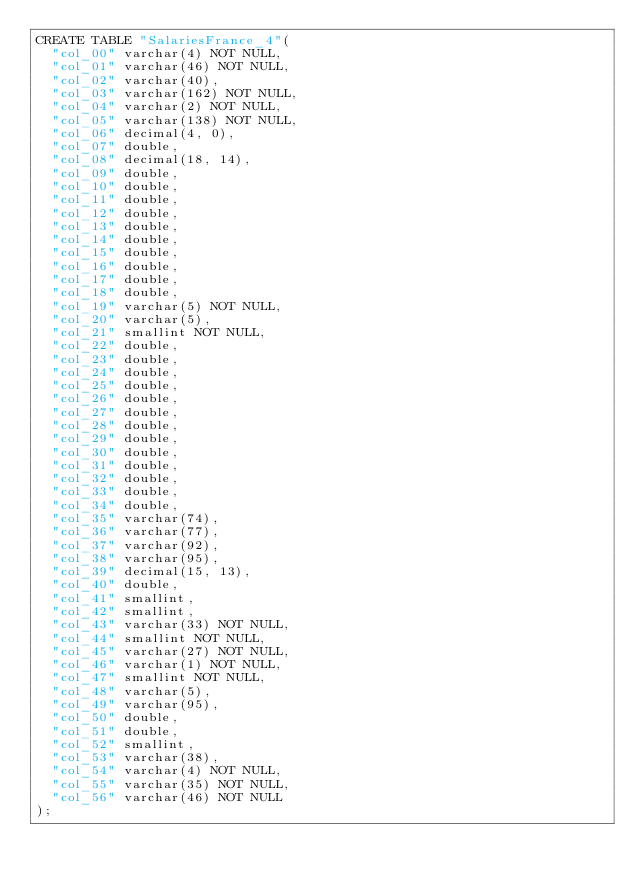<code> <loc_0><loc_0><loc_500><loc_500><_SQL_>CREATE TABLE "SalariesFrance_4"(
  "col_00" varchar(4) NOT NULL,
  "col_01" varchar(46) NOT NULL,
  "col_02" varchar(40),
  "col_03" varchar(162) NOT NULL,
  "col_04" varchar(2) NOT NULL,
  "col_05" varchar(138) NOT NULL,
  "col_06" decimal(4, 0),
  "col_07" double,
  "col_08" decimal(18, 14),
  "col_09" double,
  "col_10" double,
  "col_11" double,
  "col_12" double,
  "col_13" double,
  "col_14" double,
  "col_15" double,
  "col_16" double,
  "col_17" double,
  "col_18" double,
  "col_19" varchar(5) NOT NULL,
  "col_20" varchar(5),
  "col_21" smallint NOT NULL,
  "col_22" double,
  "col_23" double,
  "col_24" double,
  "col_25" double,
  "col_26" double,
  "col_27" double,
  "col_28" double,
  "col_29" double,
  "col_30" double,
  "col_31" double,
  "col_32" double,
  "col_33" double,
  "col_34" double,
  "col_35" varchar(74),
  "col_36" varchar(77),
  "col_37" varchar(92),
  "col_38" varchar(95),
  "col_39" decimal(15, 13),
  "col_40" double,
  "col_41" smallint,
  "col_42" smallint,
  "col_43" varchar(33) NOT NULL,
  "col_44" smallint NOT NULL,
  "col_45" varchar(27) NOT NULL,
  "col_46" varchar(1) NOT NULL,
  "col_47" smallint NOT NULL,
  "col_48" varchar(5),
  "col_49" varchar(95),
  "col_50" double,
  "col_51" double,
  "col_52" smallint,
  "col_53" varchar(38),
  "col_54" varchar(4) NOT NULL,
  "col_55" varchar(35) NOT NULL,
  "col_56" varchar(46) NOT NULL
);
</code> 